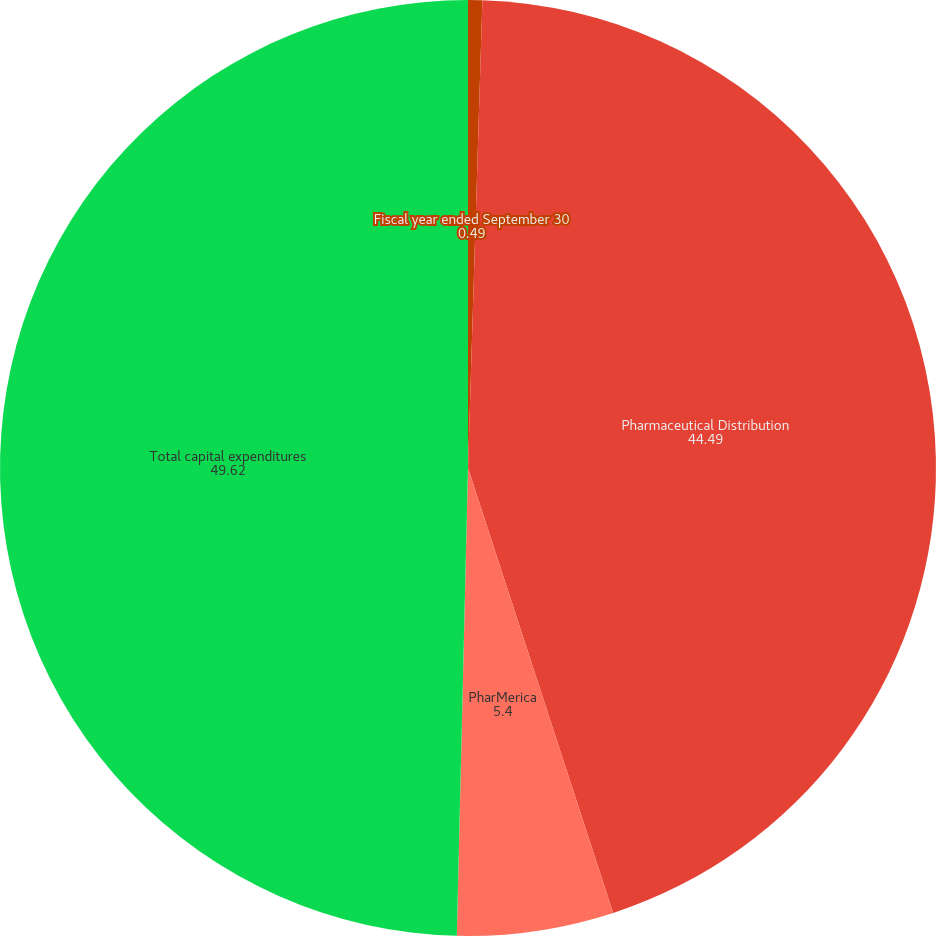Convert chart to OTSL. <chart><loc_0><loc_0><loc_500><loc_500><pie_chart><fcel>Fiscal year ended September 30<fcel>Pharmaceutical Distribution<fcel>PharMerica<fcel>Total capital expenditures<nl><fcel>0.49%<fcel>44.49%<fcel>5.4%<fcel>49.62%<nl></chart> 